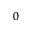Convert formula to latex. <formula><loc_0><loc_0><loc_500><loc_500>_ { 0 }</formula> 